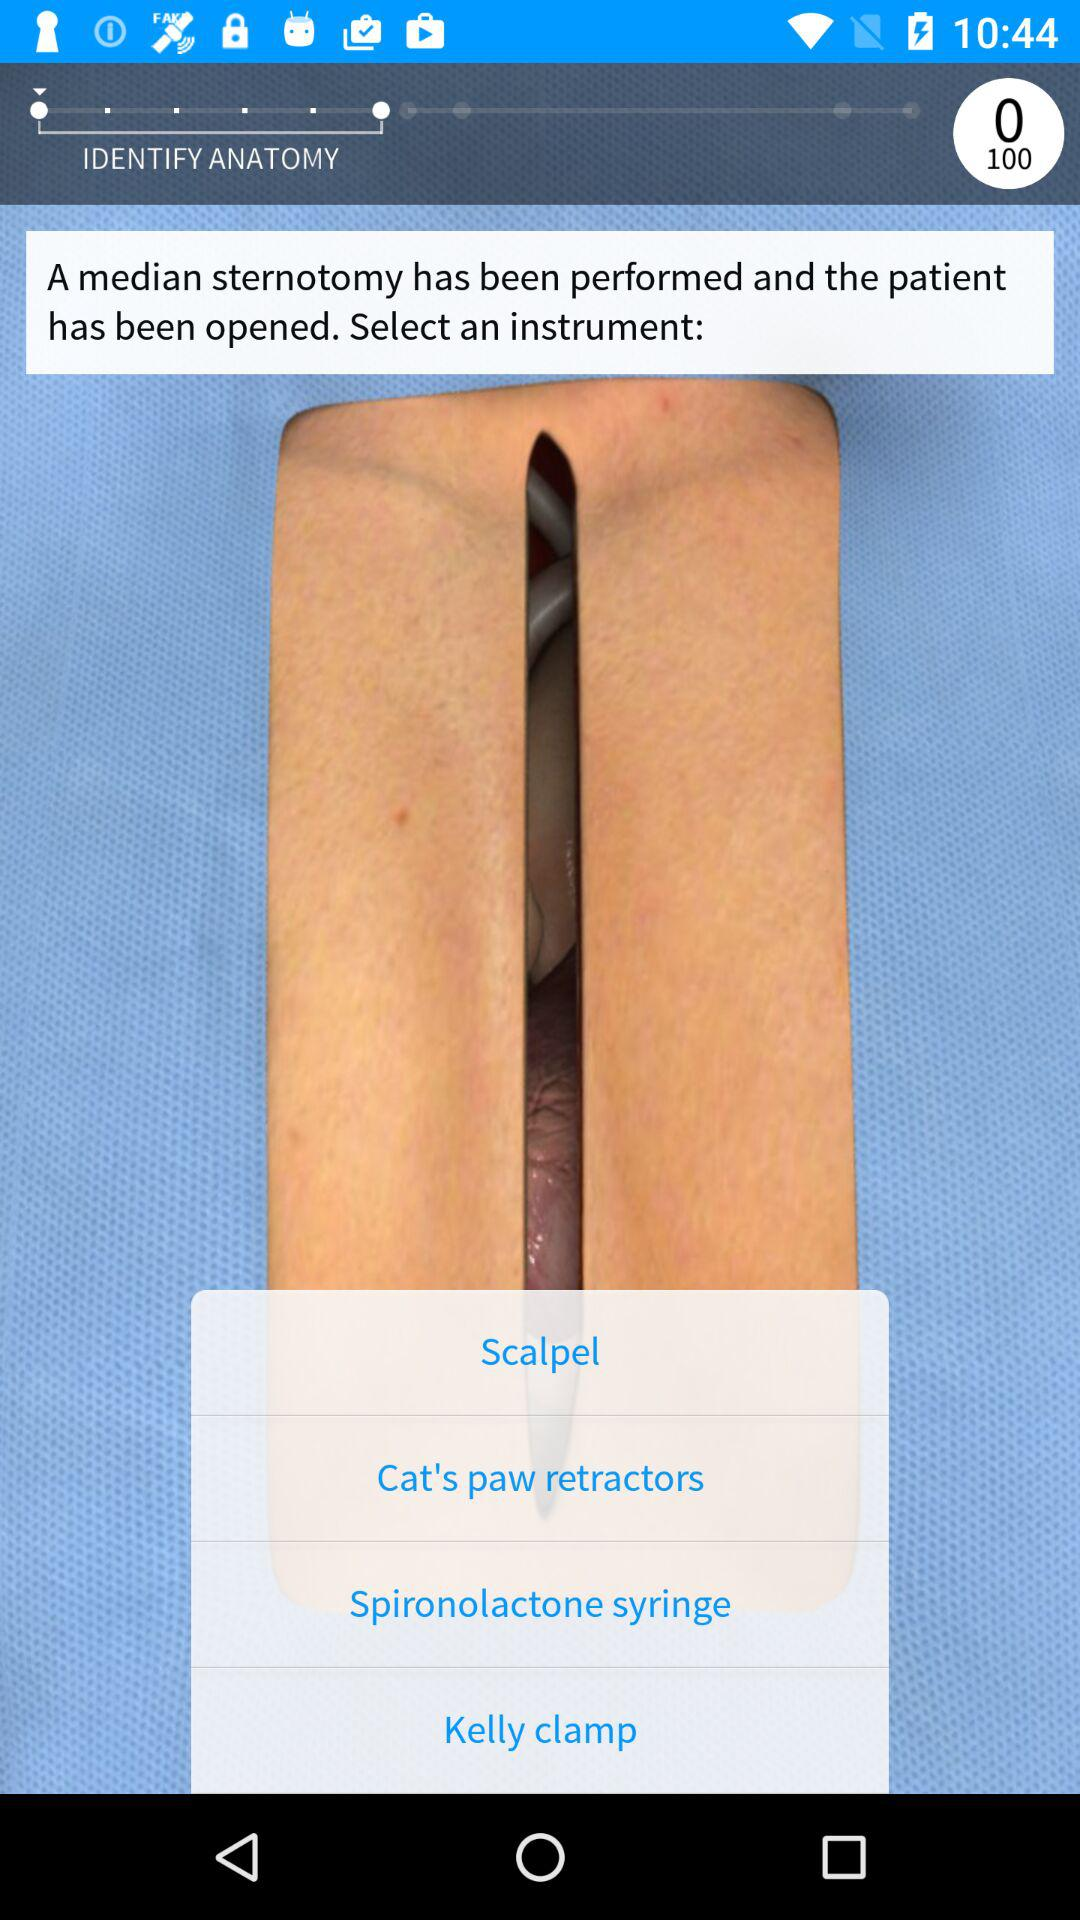What is the total number of questions? The total number of questions is 100. 